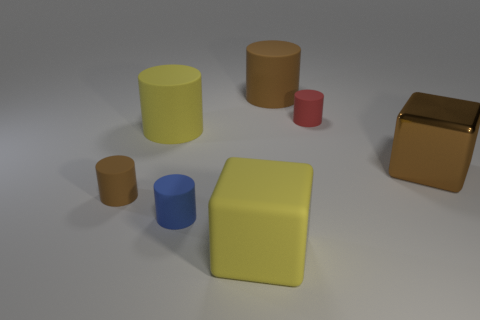Subtract all yellow cylinders. How many cylinders are left? 4 Subtract all large brown matte cylinders. How many cylinders are left? 4 Subtract all green cylinders. Subtract all yellow cubes. How many cylinders are left? 5 Add 3 yellow rubber cylinders. How many objects exist? 10 Subtract all cubes. How many objects are left? 5 Add 1 big yellow cylinders. How many big yellow cylinders are left? 2 Add 4 big brown matte things. How many big brown matte things exist? 5 Subtract 0 green balls. How many objects are left? 7 Subtract all big blue shiny cylinders. Subtract all small blue rubber cylinders. How many objects are left? 6 